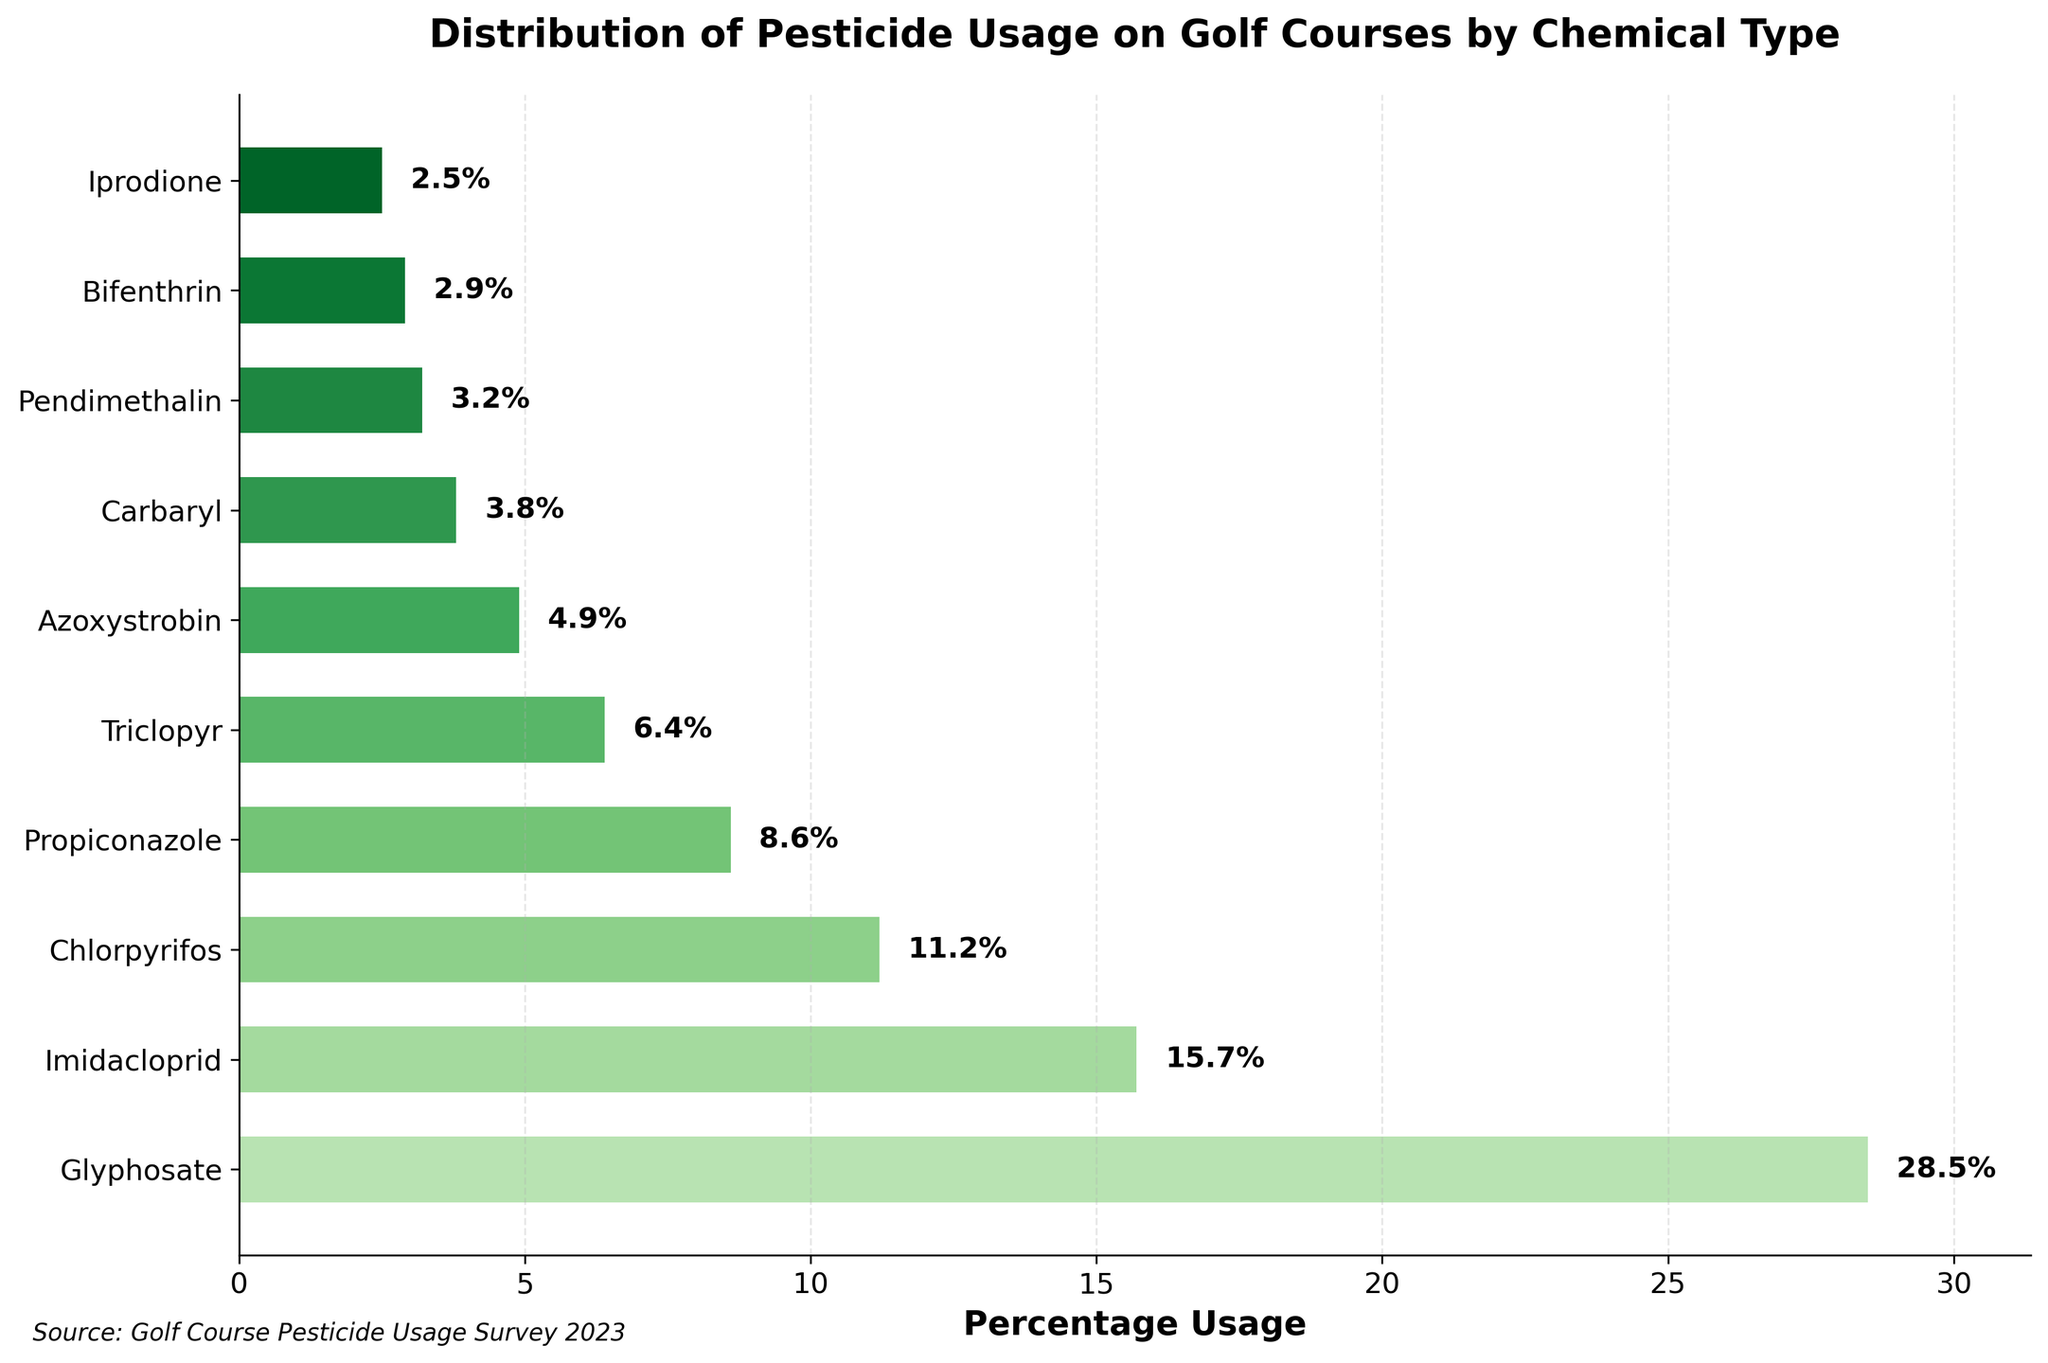Which chemical type has the highest percentage of pesticide usage on golf courses? The highest bar in the plot corresponds to Glyphosate with a percentage usage of 28.5%.
Answer: Glyphosate Which two chemical types have the closest percentage usage values? The bars for Propiconazole and Triclopyr are close to each other, with percentages of 8.6% and 6.4% respectively. Thus, the difference between them is 2.2 percentage points, which is smaller than the difference between any other adjacent bars.
Answer: Propiconazole and Triclopyr What's the total percentage usage of the top three most frequently used chemical types on golf courses? The top three most frequently used chemical types are Glyphosate (28.5%), Imidacloprid (15.7%), and Chlorpyrifos (11.2%). Adding these up: 28.5 + 15.7 + 11.2 = 55.4%.
Answer: 55.4% Compare the usage percentage of Glyphosate and Carbaryl. How much more is Glyphosate used compared to Carbaryl? Glyphosate has a usage percentage of 28.5%, while Carbaryl has 3.8%. The difference is 28.5 - 3.8 = 24.7%.
Answer: 24.7% What percentage of pesticide usage is attributed to chemical types with a usage below 5%? The chemical types are Azoxystrobin (4.9%), Carbaryl (3.8%), Pendimethalin (3.2%), Bifenthrin (2.9%), and Iprodione (2.5%). Adding these up: 4.9 + 3.8 + 3.2 + 2.9 + 2.5 = 17.3%.
Answer: 17.3% Which chemical type is used more: Chlorpyrifos or Propiconazole? By how much? Chlorpyrifos has a percentage usage of 11.2%, while Propiconazole has 8.6%. The difference is 11.2 - 8.6 = 2.6%.
Answer: Chlorpyrifos by 2.6% Are there more chemical types used above or below 10% usage? Counting the bars, there are 3 chemical types with usage above 10% (Glyphosate, Imidacloprid, Chlorpyrifos) and 7 below 10%.
Answer: Below 10% What is the percentage usage range (difference between the highest and lowest values) of all chemical types? The highest percentage usage is Glyphosate at 28.5%, and the lowest is Iprodione at 2.5%. The range is 28.5 - 2.5 = 26%.
Answer: 26% What is the average percentage usage of all chemical types presented in the plot? Add all percentage usage values: 28.5 + 15.7 + 11.2 + 8.6 + 6.4 + 4.9 + 3.8 + 3.2 + 2.9 + 2.5 = 87.7. Divide by the number of chemical types (10): 87.7 / 10 = 8.77%.
Answer: 8.77% 